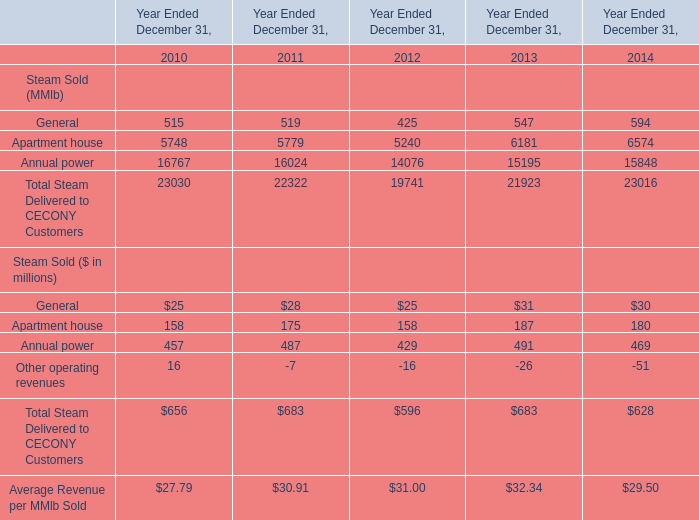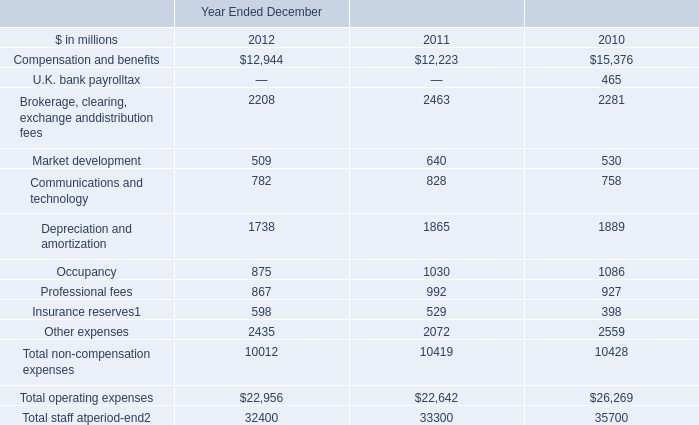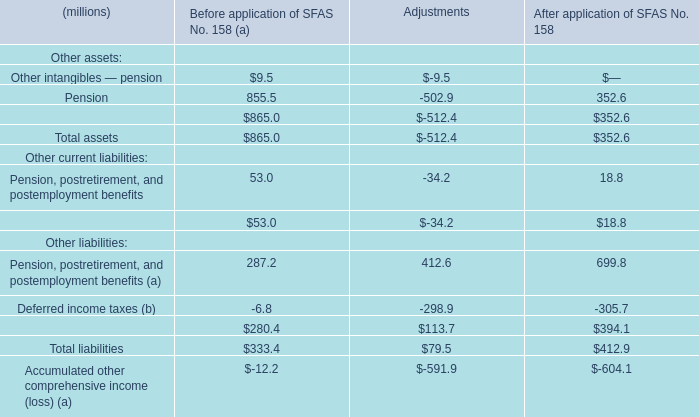What's the sum of Annual power of Year Ended December 31, 2011, and Depreciation and amortization of Year Ended December 2010 ? 
Computations: (16024.0 + 1889.0)
Answer: 17913.0. 